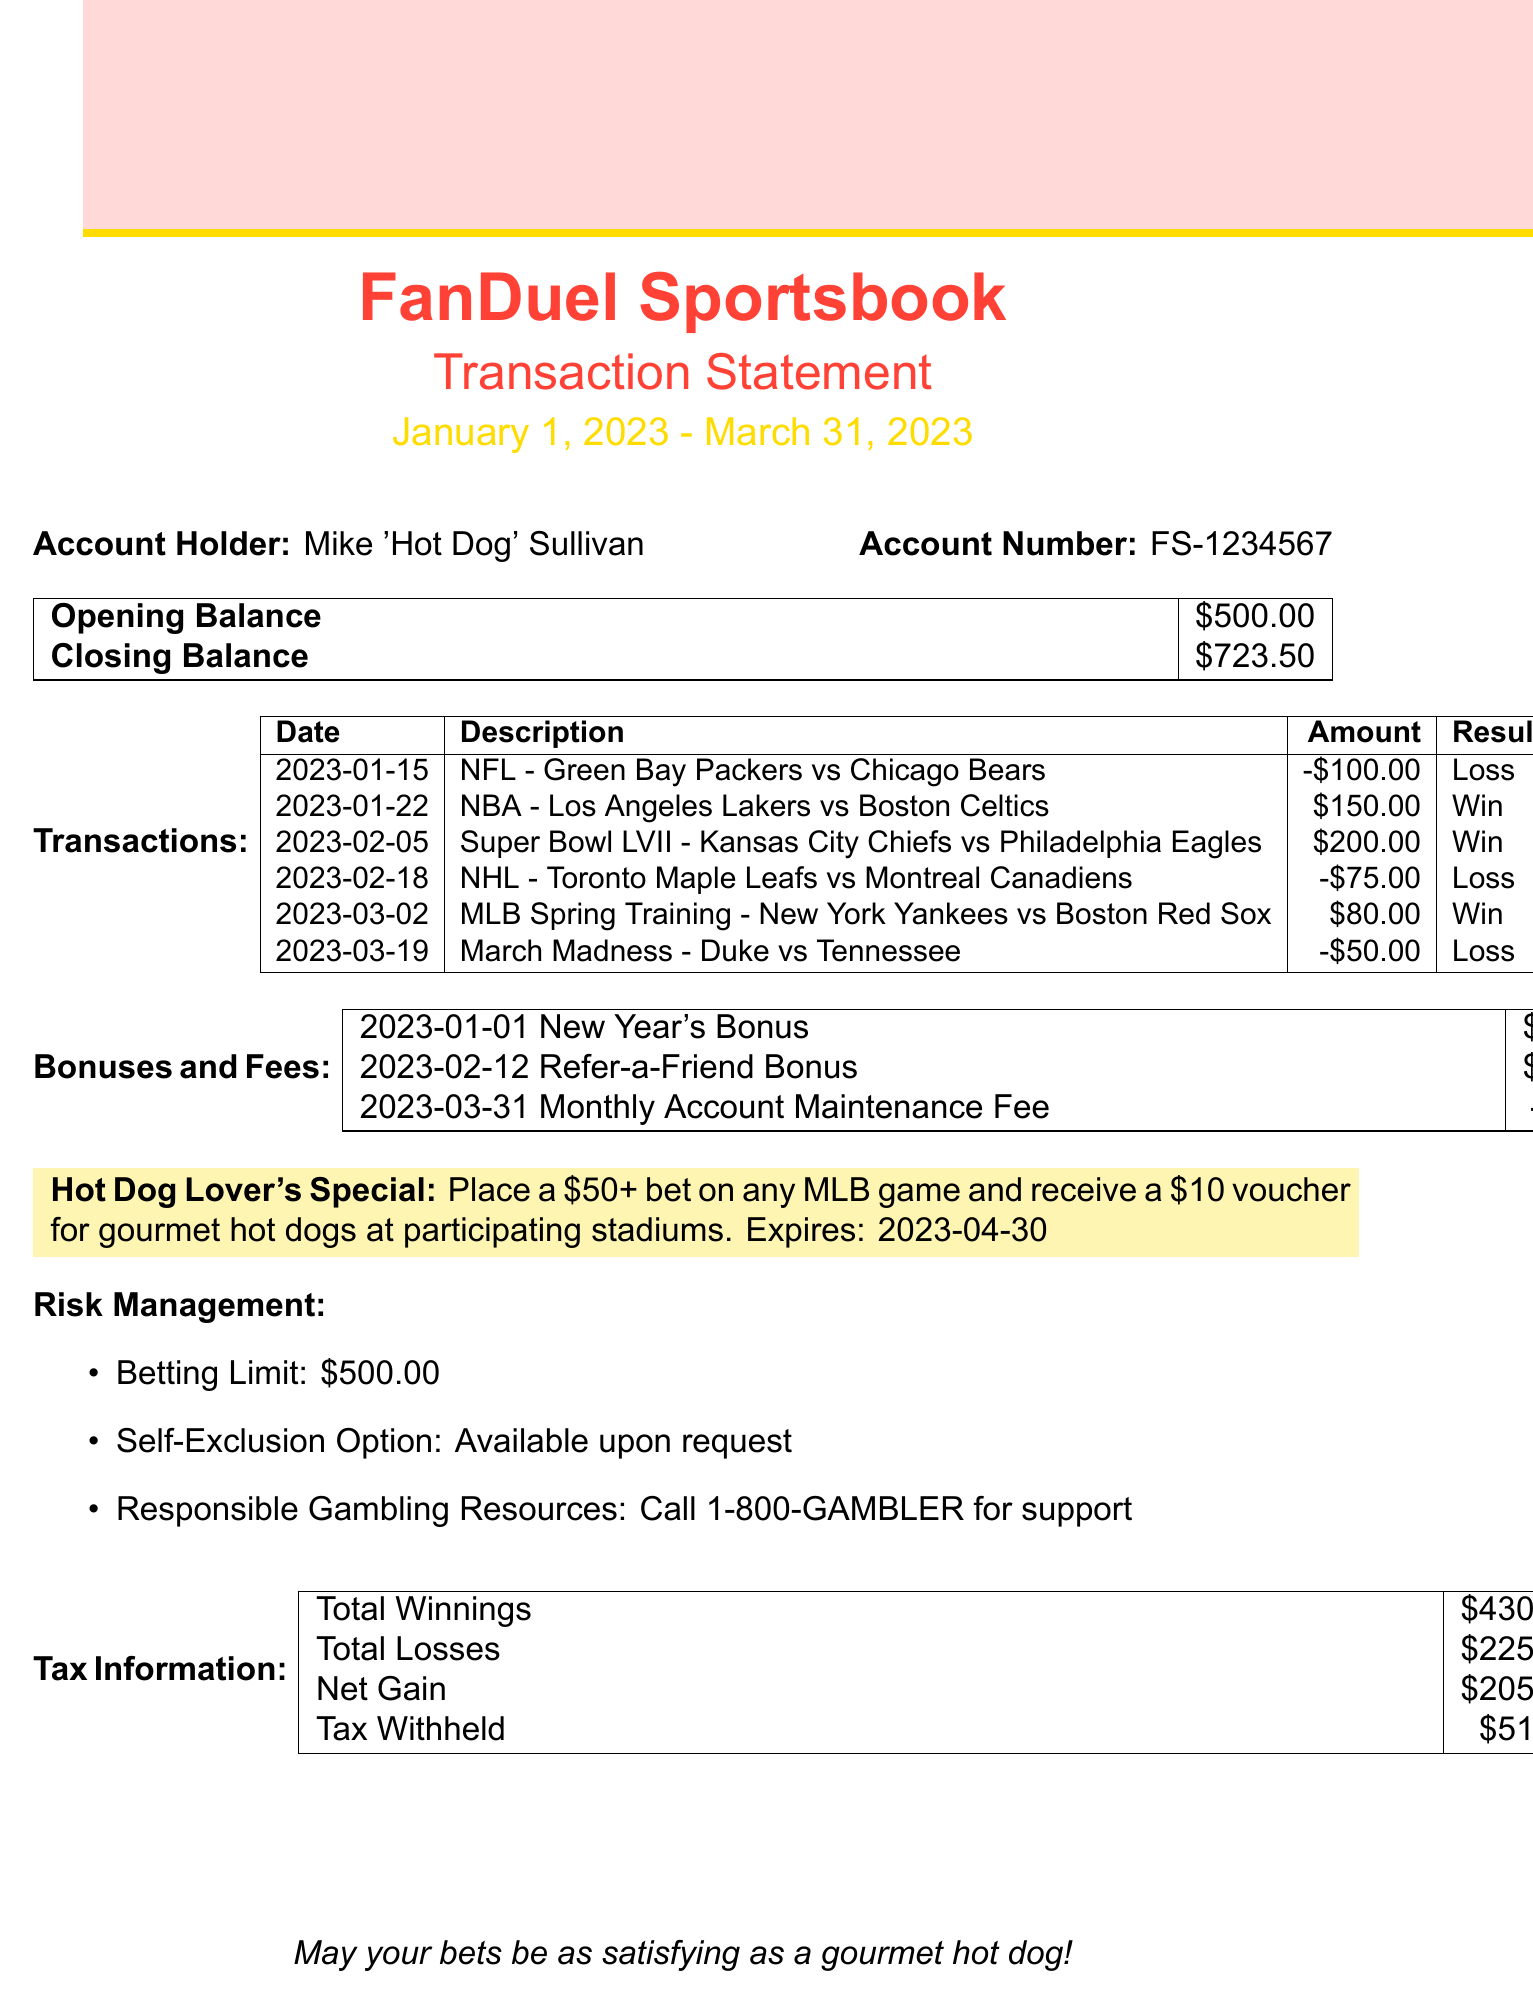What is the account holder's name? The account holder's name is explicitly stated at the top of the document.
Answer: Mike 'Hot Dog' Sullivan What is the account number? The account number is listed alongside the account holder's name for identification.
Answer: FS-1234567 What is the closing balance of the account? The closing balance appears prominently in the balance table within the document.
Answer: $723.50 How many wins are there in the transactions? By counting the transactions marked as 'Win' in the document, we find the total number of wins.
Answer: 3 What is the total amount of losses? The total losses are calculated by summing all amounts associated with transactions labeled as 'Loss'.
Answer: $225.00 What bonuses were received during the statement period? The bonuses are listed in a specific section of the document detailing the date and amount.
Answer: New Year's Bonus, Refer-a-Friend Bonus What is the date of the last transaction? The last transaction date can be found at the bottom of the transaction list.
Answer: 2023-03-19 What was the amount of the largest winning bet? The largest winning amount reflects in the transaction descriptions provided.
Answer: $200.00 What is the amount withheld for taxes? The tax information section clearly states the amount of tax withheld.
Answer: $51.25 